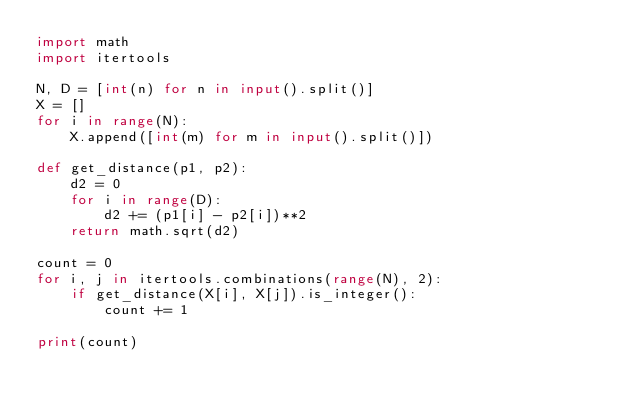Convert code to text. <code><loc_0><loc_0><loc_500><loc_500><_Python_>import math
import itertools

N, D = [int(n) for n in input().split()]
X = []
for i in range(N):
    X.append([int(m) for m in input().split()])

def get_distance(p1, p2):
    d2 = 0
    for i in range(D):
        d2 += (p1[i] - p2[i])**2
    return math.sqrt(d2)

count = 0
for i, j in itertools.combinations(range(N), 2):
    if get_distance(X[i], X[j]).is_integer():
        count += 1

print(count)</code> 